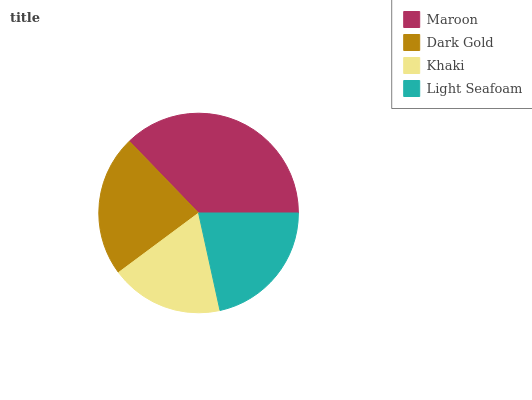Is Khaki the minimum?
Answer yes or no. Yes. Is Maroon the maximum?
Answer yes or no. Yes. Is Dark Gold the minimum?
Answer yes or no. No. Is Dark Gold the maximum?
Answer yes or no. No. Is Maroon greater than Dark Gold?
Answer yes or no. Yes. Is Dark Gold less than Maroon?
Answer yes or no. Yes. Is Dark Gold greater than Maroon?
Answer yes or no. No. Is Maroon less than Dark Gold?
Answer yes or no. No. Is Dark Gold the high median?
Answer yes or no. Yes. Is Light Seafoam the low median?
Answer yes or no. Yes. Is Light Seafoam the high median?
Answer yes or no. No. Is Maroon the low median?
Answer yes or no. No. 